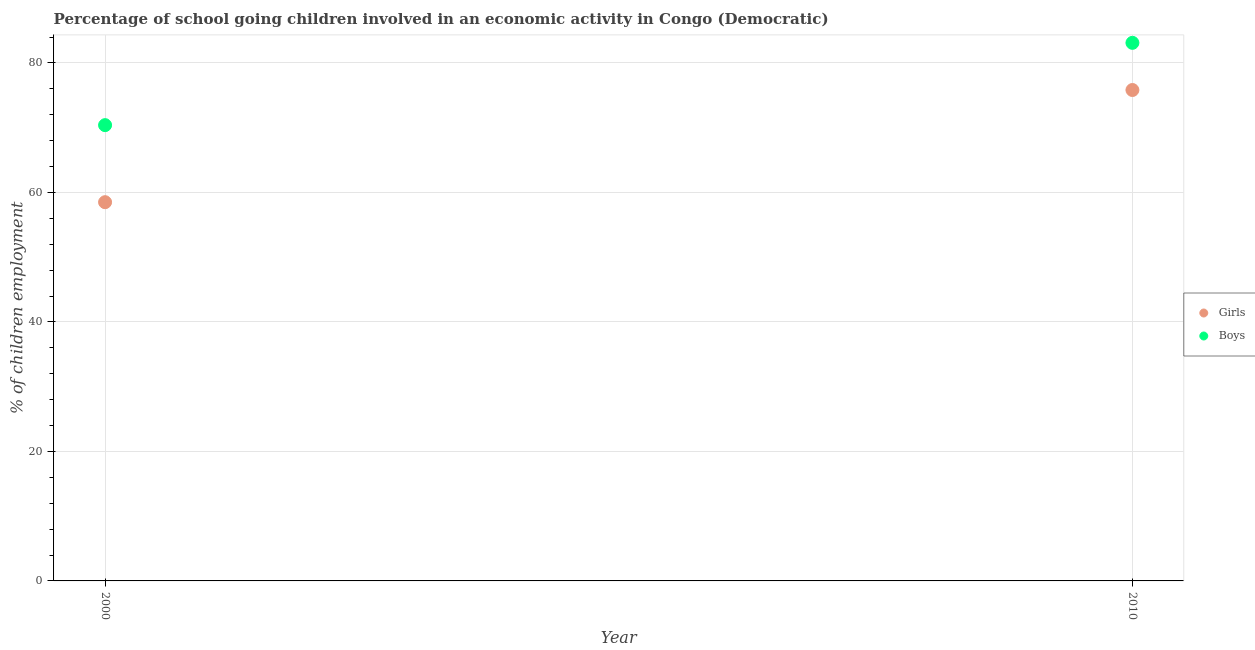How many different coloured dotlines are there?
Ensure brevity in your answer.  2. What is the percentage of school going girls in 2010?
Keep it short and to the point. 75.83. Across all years, what is the maximum percentage of school going boys?
Offer a very short reply. 83.11. Across all years, what is the minimum percentage of school going boys?
Keep it short and to the point. 70.4. In which year was the percentage of school going boys minimum?
Provide a succinct answer. 2000. What is the total percentage of school going girls in the graph?
Offer a very short reply. 134.33. What is the difference between the percentage of school going girls in 2000 and that in 2010?
Your answer should be compact. -17.33. What is the difference between the percentage of school going girls in 2010 and the percentage of school going boys in 2000?
Provide a succinct answer. 5.43. What is the average percentage of school going girls per year?
Your response must be concise. 67.16. In the year 2010, what is the difference between the percentage of school going girls and percentage of school going boys?
Offer a terse response. -7.29. In how many years, is the percentage of school going girls greater than 28 %?
Ensure brevity in your answer.  2. What is the ratio of the percentage of school going girls in 2000 to that in 2010?
Your answer should be compact. 0.77. Does the percentage of school going boys monotonically increase over the years?
Ensure brevity in your answer.  Yes. Is the percentage of school going boys strictly less than the percentage of school going girls over the years?
Ensure brevity in your answer.  No. How many years are there in the graph?
Offer a very short reply. 2. What is the difference between two consecutive major ticks on the Y-axis?
Ensure brevity in your answer.  20. Are the values on the major ticks of Y-axis written in scientific E-notation?
Make the answer very short. No. Does the graph contain grids?
Give a very brief answer. Yes. Where does the legend appear in the graph?
Your response must be concise. Center right. How many legend labels are there?
Offer a terse response. 2. What is the title of the graph?
Make the answer very short. Percentage of school going children involved in an economic activity in Congo (Democratic). What is the label or title of the Y-axis?
Offer a terse response. % of children employment. What is the % of children employment of Girls in 2000?
Provide a succinct answer. 58.5. What is the % of children employment in Boys in 2000?
Offer a very short reply. 70.4. What is the % of children employment of Girls in 2010?
Make the answer very short. 75.83. What is the % of children employment of Boys in 2010?
Your answer should be compact. 83.11. Across all years, what is the maximum % of children employment in Girls?
Provide a succinct answer. 75.83. Across all years, what is the maximum % of children employment in Boys?
Offer a terse response. 83.11. Across all years, what is the minimum % of children employment in Girls?
Ensure brevity in your answer.  58.5. Across all years, what is the minimum % of children employment in Boys?
Give a very brief answer. 70.4. What is the total % of children employment of Girls in the graph?
Your answer should be very brief. 134.33. What is the total % of children employment in Boys in the graph?
Ensure brevity in your answer.  153.51. What is the difference between the % of children employment of Girls in 2000 and that in 2010?
Your response must be concise. -17.33. What is the difference between the % of children employment of Boys in 2000 and that in 2010?
Keep it short and to the point. -12.71. What is the difference between the % of children employment of Girls in 2000 and the % of children employment of Boys in 2010?
Provide a succinct answer. -24.61. What is the average % of children employment of Girls per year?
Make the answer very short. 67.16. What is the average % of children employment in Boys per year?
Ensure brevity in your answer.  76.76. In the year 2010, what is the difference between the % of children employment in Girls and % of children employment in Boys?
Your answer should be very brief. -7.29. What is the ratio of the % of children employment of Girls in 2000 to that in 2010?
Provide a succinct answer. 0.77. What is the ratio of the % of children employment in Boys in 2000 to that in 2010?
Offer a very short reply. 0.85. What is the difference between the highest and the second highest % of children employment of Girls?
Your answer should be compact. 17.33. What is the difference between the highest and the second highest % of children employment in Boys?
Give a very brief answer. 12.71. What is the difference between the highest and the lowest % of children employment of Girls?
Offer a very short reply. 17.33. What is the difference between the highest and the lowest % of children employment in Boys?
Your answer should be very brief. 12.71. 